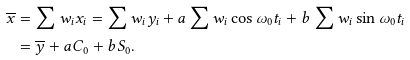Convert formula to latex. <formula><loc_0><loc_0><loc_500><loc_500>\overline { x } & = \sum w _ { i } x _ { i } = \sum w _ { i } y _ { i } + a \sum w _ { i } \cos \omega _ { 0 } t _ { i } + b \sum w _ { i } \sin \omega _ { 0 } t _ { i } \\ & = \overline { y } + a C _ { 0 } + b S _ { 0 } .</formula> 